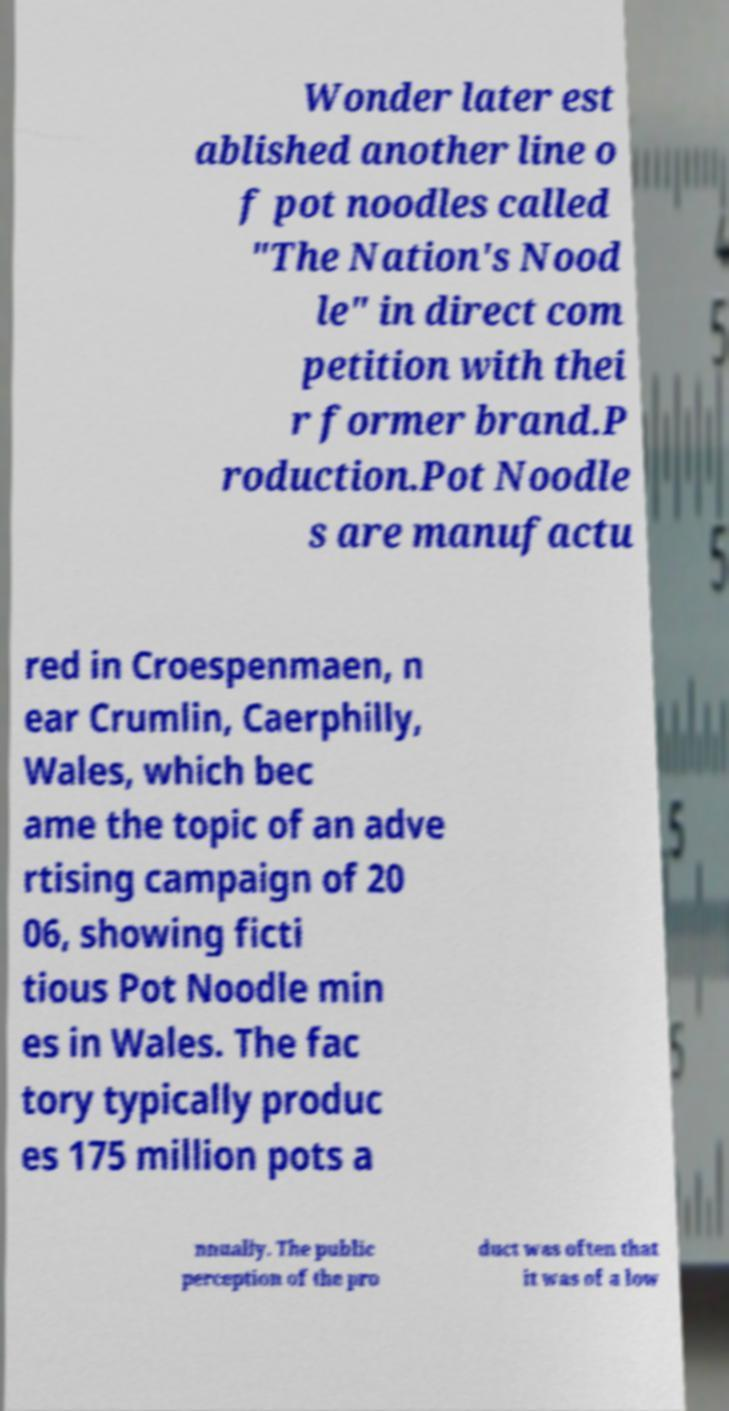Could you extract and type out the text from this image? Wonder later est ablished another line o f pot noodles called "The Nation's Nood le" in direct com petition with thei r former brand.P roduction.Pot Noodle s are manufactu red in Croespenmaen, n ear Crumlin, Caerphilly, Wales, which bec ame the topic of an adve rtising campaign of 20 06, showing ficti tious Pot Noodle min es in Wales. The fac tory typically produc es 175 million pots a nnually. The public perception of the pro duct was often that it was of a low 